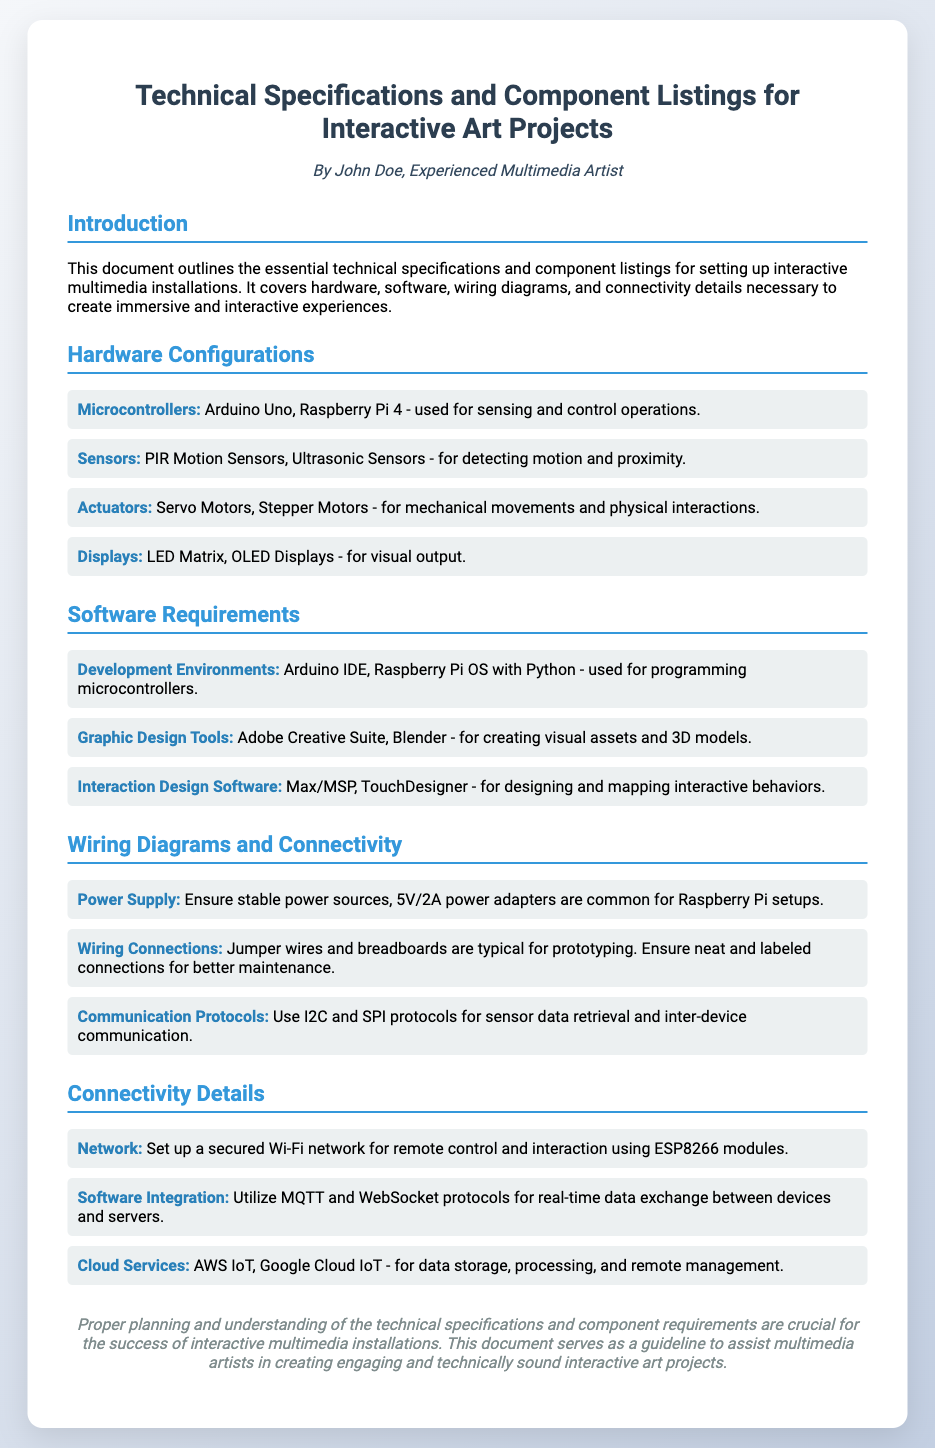What are the two types of microcontrollers mentioned? The document lists Arduino Uno and Raspberry Pi 4 as the microcontrollers used for sensing and control operations.
Answer: Arduino Uno, Raspberry Pi 4 What is the suggested power supply rating for the Raspberry Pi setups? The document specifies that a 5V/2A power adapter is common for Raspberry Pi setups as a power supply.
Answer: 5V/2A Which software is used for graphic design? According to the document, Adobe Creative Suite and Blender are listed as tools for creating visual assets and 3D models.
Answer: Adobe Creative Suite, Blender What communication protocols are recommended for inter-device communication? The document indicates that I2C and SPI protocols should be used for sensor data retrieval and inter-device communication.
Answer: I2C, SPI What type of network is recommended for remote control? The document advises setting up a secured Wi-Fi network using ESP8266 modules for remote control and interaction.
Answer: Secured Wi-Fi network How many types of sensors are listed in the document? The document mentions two types of sensors: PIR Motion Sensors and Ultrasonic Sensors, indicating that two sensor types are listed.
Answer: Two What is the main purpose of this document? The document outlines essential technical specifications and component listings for setting up interactive multimedia installations.
Answer: Guidelines for interactive multimedia installations What is the color of the heading for the "Hardware Configurations" section? The document describes the heading for the "Hardware Configurations" section as colored in a specific shade of blue, #3498db.
Answer: #3498db 